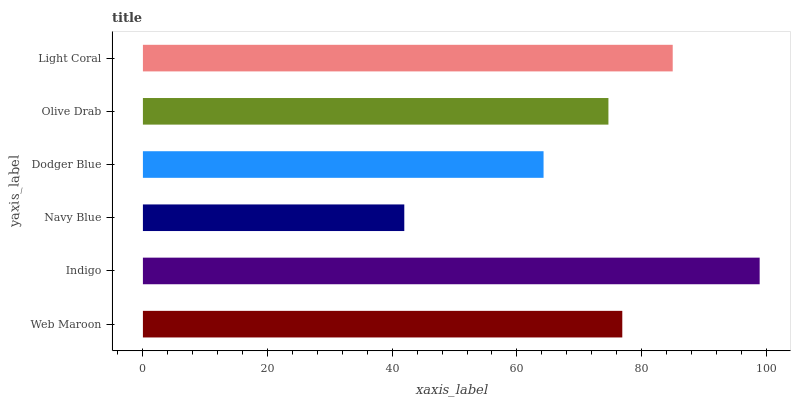Is Navy Blue the minimum?
Answer yes or no. Yes. Is Indigo the maximum?
Answer yes or no. Yes. Is Indigo the minimum?
Answer yes or no. No. Is Navy Blue the maximum?
Answer yes or no. No. Is Indigo greater than Navy Blue?
Answer yes or no. Yes. Is Navy Blue less than Indigo?
Answer yes or no. Yes. Is Navy Blue greater than Indigo?
Answer yes or no. No. Is Indigo less than Navy Blue?
Answer yes or no. No. Is Web Maroon the high median?
Answer yes or no. Yes. Is Olive Drab the low median?
Answer yes or no. Yes. Is Indigo the high median?
Answer yes or no. No. Is Indigo the low median?
Answer yes or no. No. 